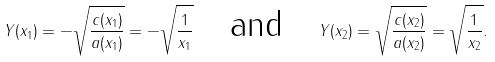<formula> <loc_0><loc_0><loc_500><loc_500>Y ( x _ { 1 } ) = - \sqrt { \frac { c ( x _ { 1 } ) } { a ( x _ { 1 } ) } } = - \sqrt { \frac { 1 } { x _ { 1 } } } \quad \text {and} \quad Y ( x _ { 2 } ) = \sqrt { \frac { c ( x _ { 2 } ) } { a ( x _ { 2 } ) } } = \sqrt { \frac { 1 } { x _ { 2 } } } .</formula> 